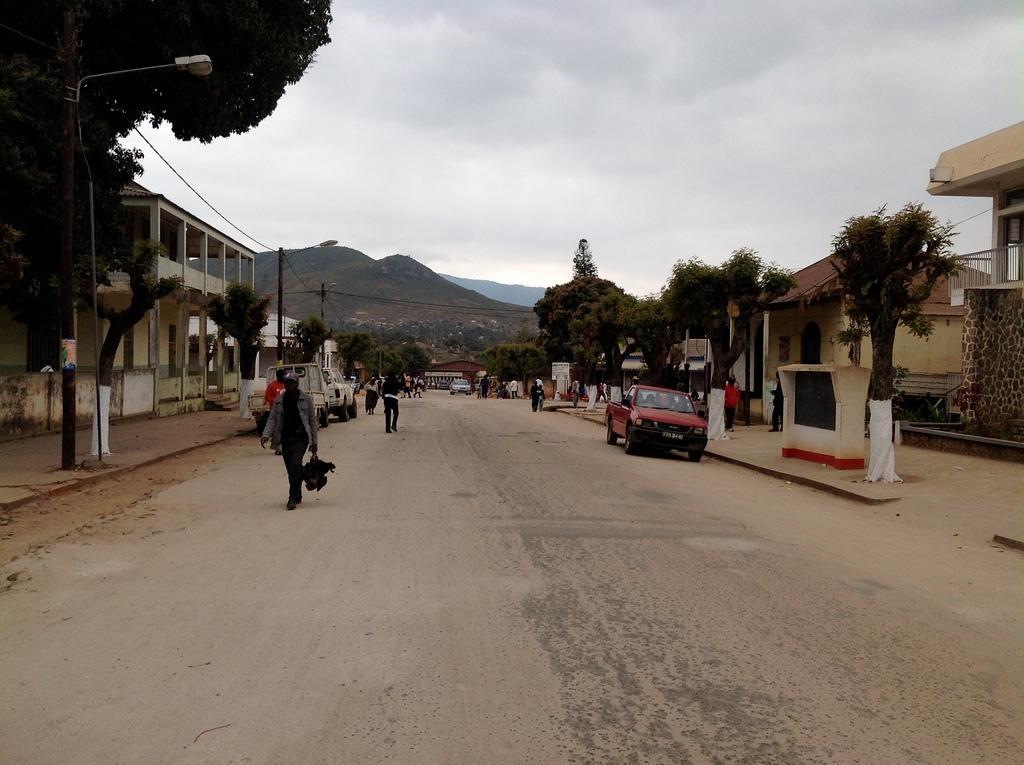Please provide a concise description of this image. In this image we can see road, vehicles, people, poles, wires, trees, lights, and houses. In the background we can see mountain and sky with clouds. 